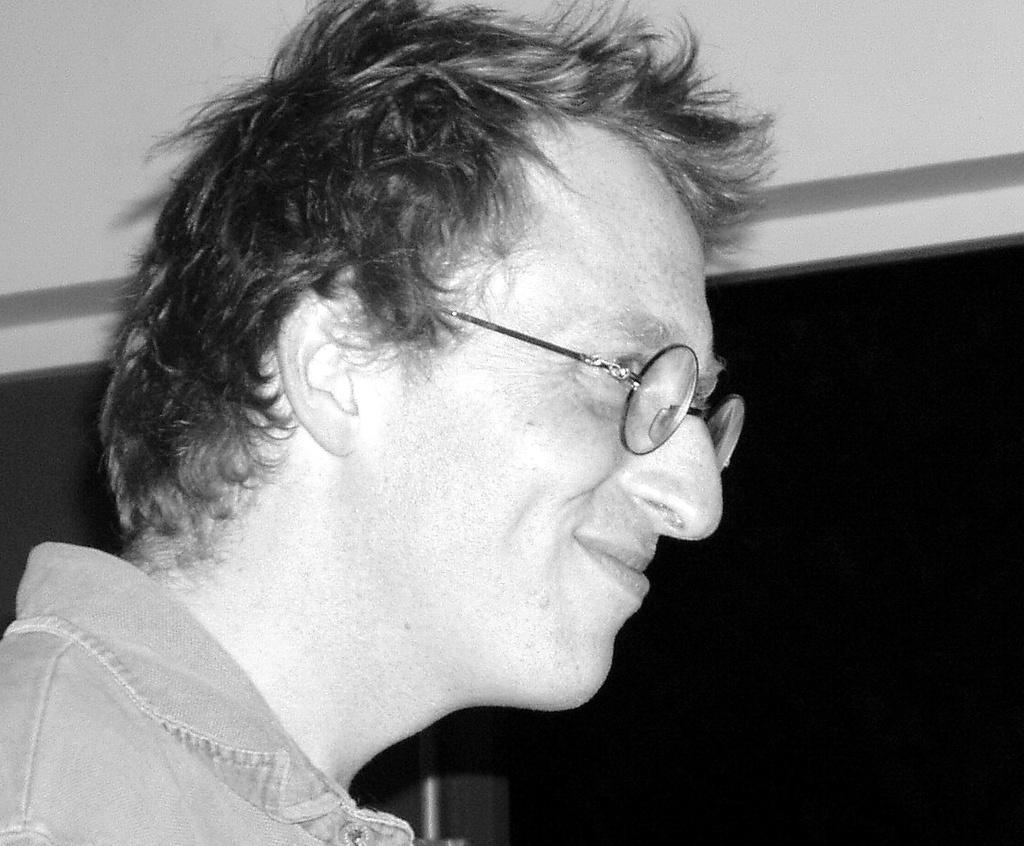What is the color scheme of the image? The image is black and white. Can you describe the person in the image? There is a person in the image, and they are smiling. What accessory is the person wearing? The person is wearing spectacles. What book is the person holding in the image? There is no book present in the image; it only features a person wearing spectacles and smiling. 